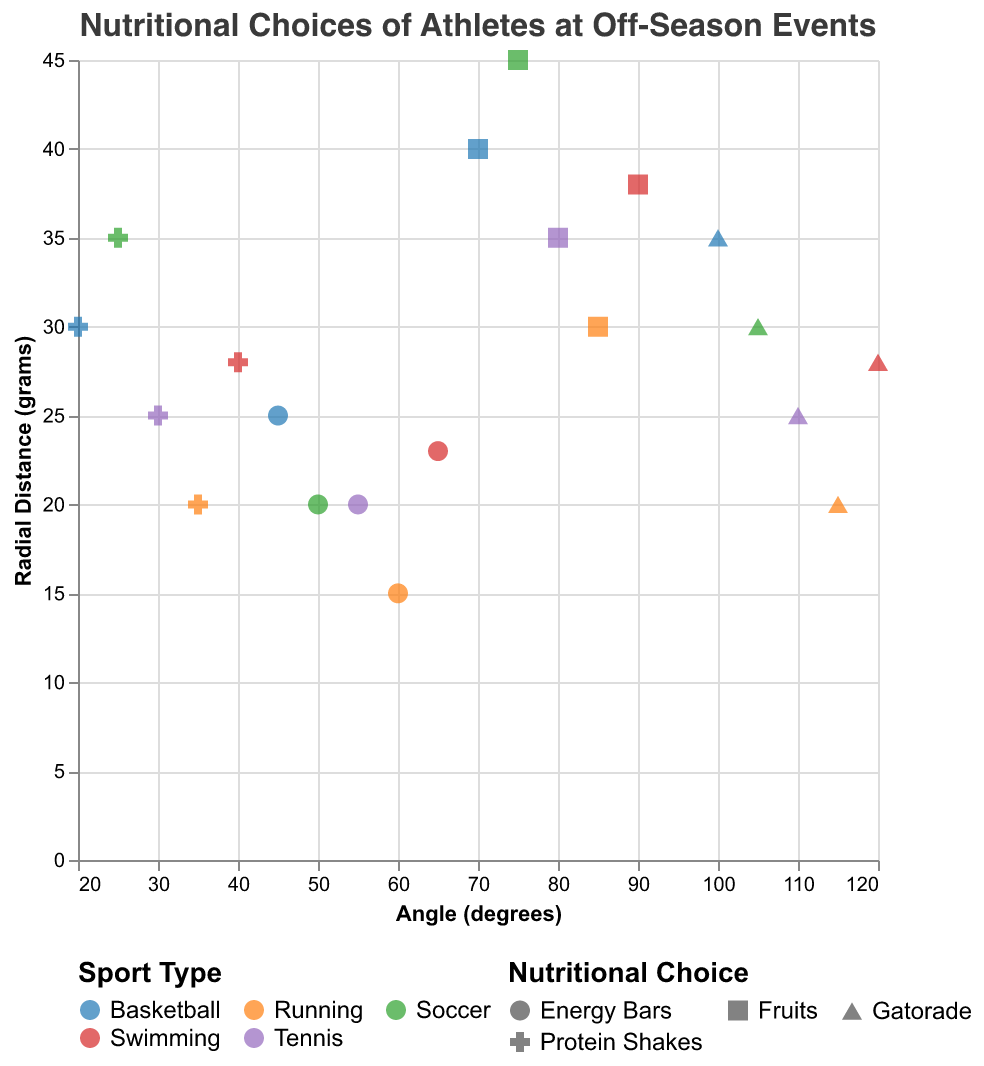What's the most common nutritional choice among basketball players, based on radial distance? Compare the radial distances representing different nutritional choices for basketball players and identify the highest value. Fruits have the highest radial distance (40 grams).
Answer: Fruits Which sport type includes athletes who consume the highest amount of Gatorade? Check the radial distances for Gatorade across different sport types and identify the highest value. Soccer athletes consume 35 grams of Gatorade, which is the highest.
Answer: Soccer What is the total amount of energy bars consumed by runners and tennis players? Sum the radial distances for energy bars consumed by both runners (15 grams) and tennis players (20 grams): 15 + 20 = 35 grams.
Answer: 35 grams Which nutritional choice is represented at the lowest radial distance within running? Identify the smallest radial distance among all nutritional choices for running. Energy bars have the lowest radial distance (15 grams) within running.
Answer: Energy bars Compare the amount of protein shakes consumed by soccer players and basketball players. Compare the radial distances for protein shakes consumed by soccer (35 grams) and basketball (30 grams) players. Soccer players consume 5 grams more than basketball players.
Answer: Soccer players consume more Which sport type has the highest diversity of nutritional choices, based on the number of distinct nutritional choices represented on the chart? Check the number of unique nutritional choices for each sport. All sport types (Basketball, Soccer, Tennis, Running, Swimming) have 4 distinct choices each, indicating the diversity is the same across all sports.
Answer: All sport types have equal diversity What's the average amount of fruits consumed across all sports? Calculate the average by summing fruits consumption across all sports and dividing by the number of sports: (40 + 45 + 35 + 30 + 38)/5 = 37.6 grams.
Answer: 37.6 grams How does the consumption of energy bars among basketball players compare to that of swimmers? Compare the radial distances for energy bars consumed by basketball players (25 grams) and swimmers (23 grams). Basketball players consume 2 grams more than swimmers.
Answer: Basketball players consume more What's the relationship between the consumption of Gatorade and the angle degrees for tennis and running athletes? For Tennis, Gatorade is at 25 grams and 110 degrees; for Running, Gatorade is at 20 grams and 115 degrees. Both Gatorade consumptions are positioned near each other by angle but differ in radial distance. Tennis has slightly lower angle degrees but more amount compared to Running.
Answer: Tennis has a lower angle but higher consumption 